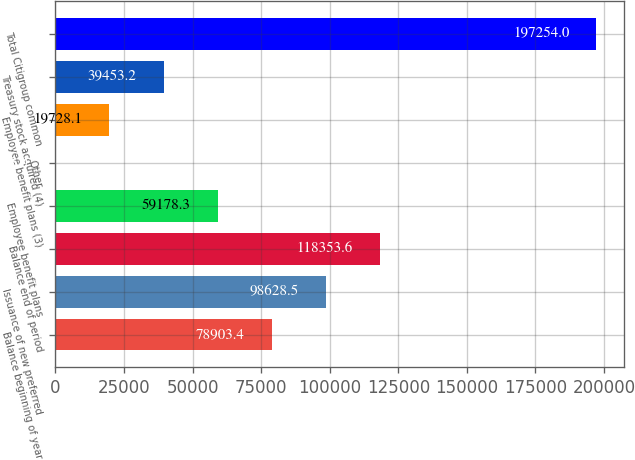Convert chart. <chart><loc_0><loc_0><loc_500><loc_500><bar_chart><fcel>Balance beginning of year<fcel>Issuance of new preferred<fcel>Balance end of period<fcel>Employee benefit plans<fcel>Other<fcel>Employee benefit plans (3)<fcel>Treasury stock acquired (4)<fcel>Total Citigroup common<nl><fcel>78903.4<fcel>98628.5<fcel>118354<fcel>59178.3<fcel>3<fcel>19728.1<fcel>39453.2<fcel>197254<nl></chart> 